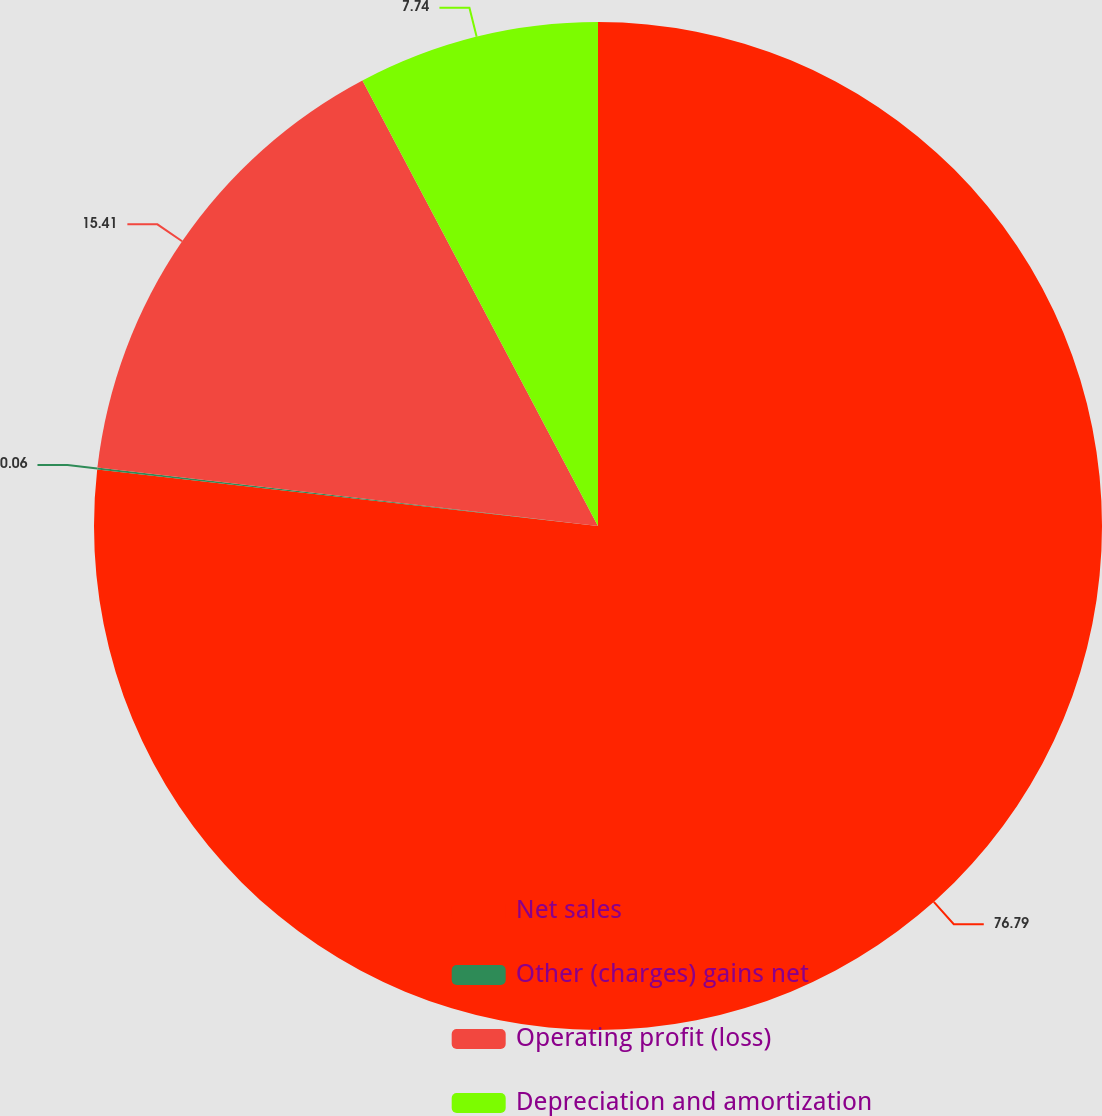<chart> <loc_0><loc_0><loc_500><loc_500><pie_chart><fcel>Net sales<fcel>Other (charges) gains net<fcel>Operating profit (loss)<fcel>Depreciation and amortization<nl><fcel>76.79%<fcel>0.06%<fcel>15.41%<fcel>7.74%<nl></chart> 